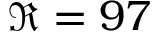<formula> <loc_0><loc_0><loc_500><loc_500>\Re = 9 7</formula> 